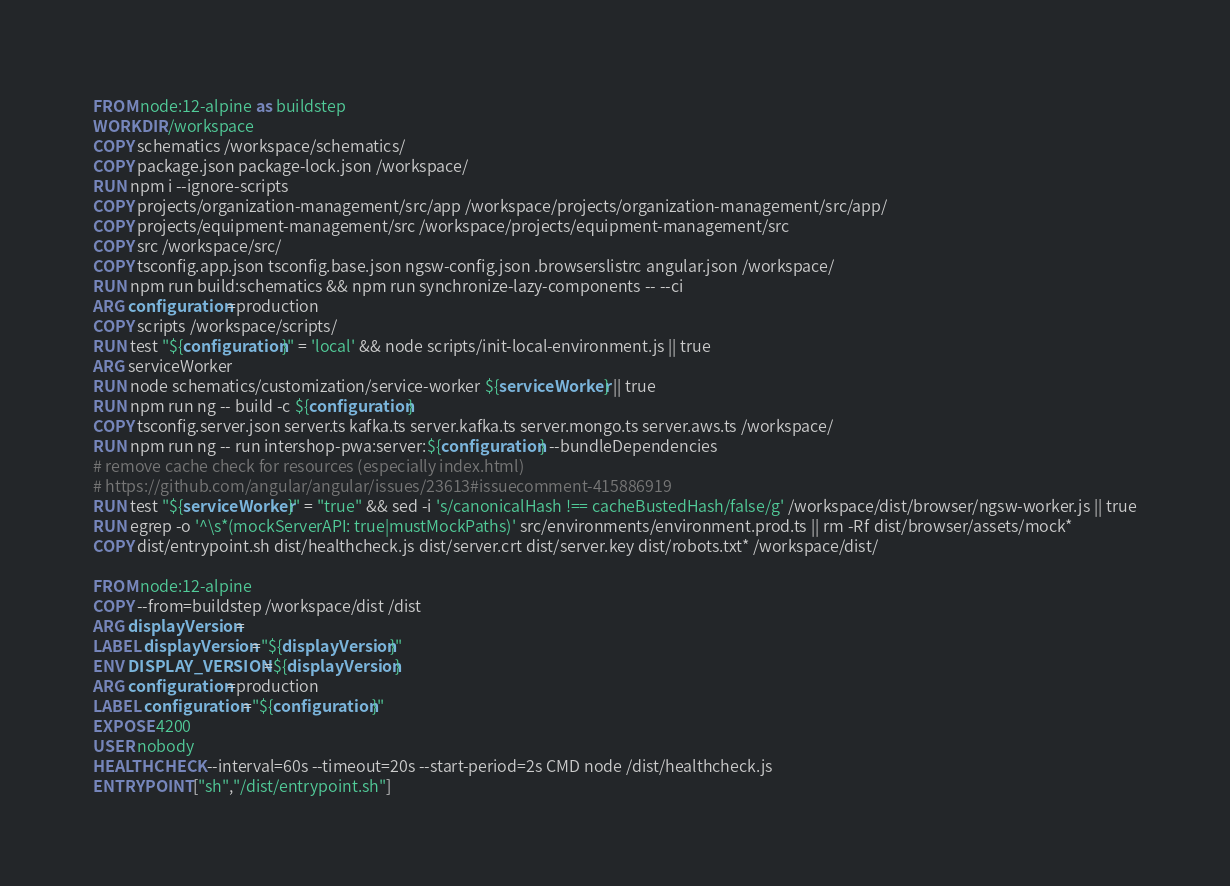<code> <loc_0><loc_0><loc_500><loc_500><_Dockerfile_>FROM node:12-alpine as buildstep
WORKDIR /workspace
COPY schematics /workspace/schematics/
COPY package.json package-lock.json /workspace/
RUN npm i --ignore-scripts
COPY projects/organization-management/src/app /workspace/projects/organization-management/src/app/
COPY projects/equipment-management/src /workspace/projects/equipment-management/src
COPY src /workspace/src/
COPY tsconfig.app.json tsconfig.base.json ngsw-config.json .browserslistrc angular.json /workspace/
RUN npm run build:schematics && npm run synchronize-lazy-components -- --ci
ARG configuration=production
COPY scripts /workspace/scripts/
RUN test "${configuration}" = 'local' && node scripts/init-local-environment.js || true
ARG serviceWorker
RUN node schematics/customization/service-worker ${serviceWorker} || true
RUN npm run ng -- build -c ${configuration}
COPY tsconfig.server.json server.ts kafka.ts server.kafka.ts server.mongo.ts server.aws.ts /workspace/
RUN npm run ng -- run intershop-pwa:server:${configuration} --bundleDependencies
# remove cache check for resources (especially index.html)
# https://github.com/angular/angular/issues/23613#issuecomment-415886919
RUN test "${serviceWorker}" = "true" && sed -i 's/canonicalHash !== cacheBustedHash/false/g' /workspace/dist/browser/ngsw-worker.js || true
RUN egrep -o '^\s*(mockServerAPI: true|mustMockPaths)' src/environments/environment.prod.ts || rm -Rf dist/browser/assets/mock*
COPY dist/entrypoint.sh dist/healthcheck.js dist/server.crt dist/server.key dist/robots.txt* /workspace/dist/

FROM node:12-alpine
COPY --from=buildstep /workspace/dist /dist
ARG displayVersion=
LABEL displayVersion="${displayVersion}"
ENV DISPLAY_VERSION=${displayVersion}
ARG configuration=production
LABEL configuration="${configuration}"
EXPOSE 4200
USER nobody
HEALTHCHECK --interval=60s --timeout=20s --start-period=2s CMD node /dist/healthcheck.js
ENTRYPOINT ["sh","/dist/entrypoint.sh"]
</code> 